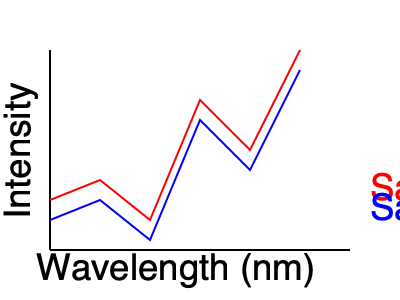Analyze the spectral graphs of two pigment samples (A and B) from different cave art sites. Based on the similarities in their spectral signatures, what can you conclude about the likely origin of these pigments? To analyze the spectral graphs and draw conclusions about the pigments' origins, we need to follow these steps:

1. Observe the overall shape of both spectral curves:
   - Both curves show similar patterns with peaks and troughs at corresponding wavelengths.

2. Compare specific features:
   - Both samples have a major peak around 200-250 nm.
   - A smaller peak is visible for both samples at approximately 100-150 nm.
   - There's a notable dip in intensity for both samples around 175-225 nm.

3. Analyze the intensity differences:
   - Sample A (red) consistently shows slightly higher intensity than Sample B (blue).
   - The relative differences in intensity between peaks and troughs are similar for both samples.

4. Consider the implications:
   - The strong similarities in spectral signatures suggest that the pigments have very similar chemical compositions.
   - Minor differences in intensity could be due to factors such as concentration, preservation, or slight variations in mineral content.

5. Draw conclusions:
   - The high degree of similarity in spectral signatures indicates that these pigments likely come from the same or very similar geological sources.
   - It's probable that the artists at both cave sites had access to the same or closely related pigment sources.

6. Archaeological interpretation:
   - This similarity suggests potential cultural connections, trade networks, or shared knowledge between the groups that created the cave art at these different sites.

Given the strong spectral similarities, we can conclude that the pigments used in both cave art sites likely originated from the same or very closely related geological sources, indicating potential cultural or trade connections between the sites.
Answer: Same or closely related geological sources, suggesting cultural or trade connections 